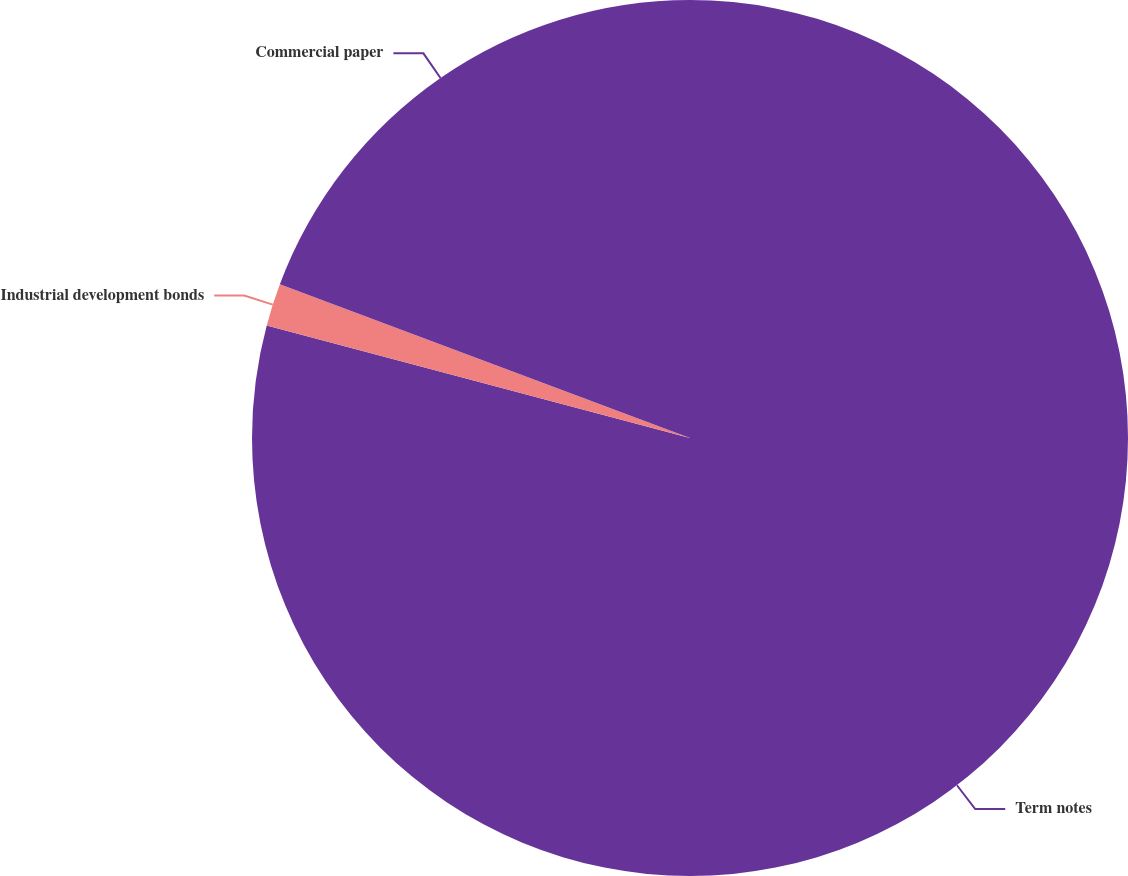<chart> <loc_0><loc_0><loc_500><loc_500><pie_chart><fcel>Term notes<fcel>Industrial development bonds<fcel>Commercial paper<nl><fcel>79.13%<fcel>1.57%<fcel>19.29%<nl></chart> 